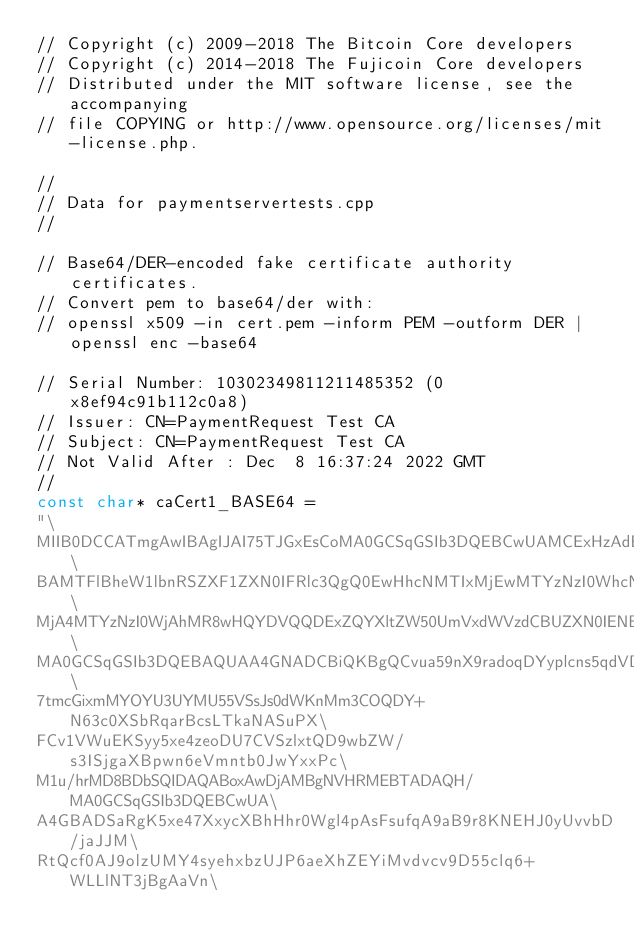<code> <loc_0><loc_0><loc_500><loc_500><_C_>// Copyright (c) 2009-2018 The Bitcoin Core developers
// Copyright (c) 2014-2018 The Fujicoin Core developers
// Distributed under the MIT software license, see the accompanying
// file COPYING or http://www.opensource.org/licenses/mit-license.php.

//
// Data for paymentservertests.cpp
//

// Base64/DER-encoded fake certificate authority certificates.
// Convert pem to base64/der with:
// openssl x509 -in cert.pem -inform PEM -outform DER | openssl enc -base64

// Serial Number: 10302349811211485352 (0x8ef94c91b112c0a8)
// Issuer: CN=PaymentRequest Test CA
// Subject: CN=PaymentRequest Test CA
// Not Valid After : Dec  8 16:37:24 2022 GMT
//
const char* caCert1_BASE64 =
"\
MIIB0DCCATmgAwIBAgIJAI75TJGxEsCoMA0GCSqGSIb3DQEBCwUAMCExHzAdBgNV\
BAMTFlBheW1lbnRSZXF1ZXN0IFRlc3QgQ0EwHhcNMTIxMjEwMTYzNzI0WhcNMjIx\
MjA4MTYzNzI0WjAhMR8wHQYDVQQDExZQYXltZW50UmVxdWVzdCBUZXN0IENBMIGf\
MA0GCSqGSIb3DQEBAQUAA4GNADCBiQKBgQCvua59nX9radoqDYyplcns5qdVDTN1\
7tmcGixmMYOYU3UYMU55VSsJs0dWKnMm3COQDY+N63c0XSbRqarBcsLTkaNASuPX\
FCv1VWuEKSyy5xe4zeoDU7CVSzlxtQD9wbZW/s3ISjgaXBpwn6eVmntb0JwYxxPc\
M1u/hrMD8BDbSQIDAQABoxAwDjAMBgNVHRMEBTADAQH/MA0GCSqGSIb3DQEBCwUA\
A4GBADSaRgK5xe47XxycXBhHhr0Wgl4pAsFsufqA9aB9r8KNEHJ0yUvvbD/jaJJM\
RtQcf0AJ9olzUMY4syehxbzUJP6aeXhZEYiMvdvcv9D55clq6+WLLlNT3jBgAaVn\</code> 